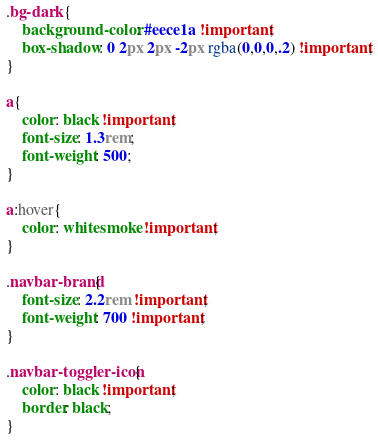Convert code to text. <code><loc_0><loc_0><loc_500><loc_500><_CSS_>.bg-dark {
    background-color: #eece1a !important;
    box-shadow: 0 2px 2px -2px rgba(0,0,0,.2) !important;
}

a{
    color: black !important;
    font-size: 1.3rem;
    font-weight: 500;
}

a:hover{
    color: whitesmoke !important;
}

.navbar-brand{
    font-size: 2.2rem !important;
    font-weight: 700 !important;
}

.navbar-toggler-icon{
    color: black !important;
    border: black;
}</code> 